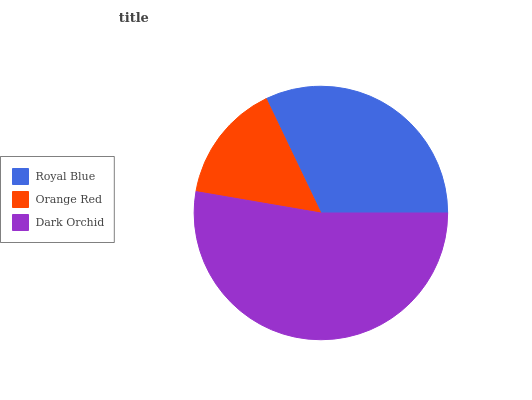Is Orange Red the minimum?
Answer yes or no. Yes. Is Dark Orchid the maximum?
Answer yes or no. Yes. Is Dark Orchid the minimum?
Answer yes or no. No. Is Orange Red the maximum?
Answer yes or no. No. Is Dark Orchid greater than Orange Red?
Answer yes or no. Yes. Is Orange Red less than Dark Orchid?
Answer yes or no. Yes. Is Orange Red greater than Dark Orchid?
Answer yes or no. No. Is Dark Orchid less than Orange Red?
Answer yes or no. No. Is Royal Blue the high median?
Answer yes or no. Yes. Is Royal Blue the low median?
Answer yes or no. Yes. Is Dark Orchid the high median?
Answer yes or no. No. Is Orange Red the low median?
Answer yes or no. No. 